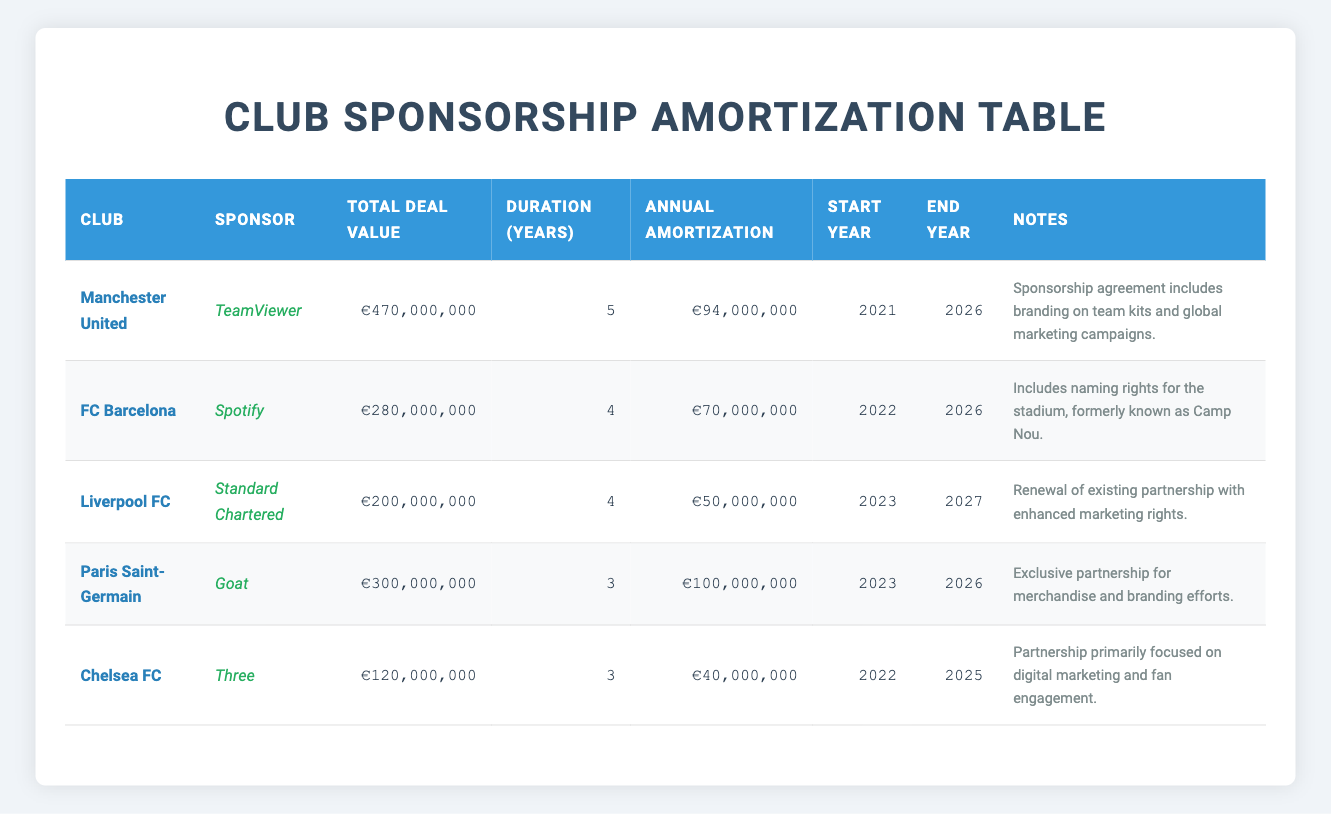What is the total deal value for FC Barcelona's sponsorship with Spotify? The total deal value for FC Barcelona's sponsorship with Spotify is listed in the table under the "Total Deal Value" column. It shows €280,000,000.
Answer: €280,000,000 Which club has the highest annual amortization and what is that amount? By examining the "Annual Amortization" column for each club, Paris Saint-Germain has the highest annual amortization of €100,000,000.
Answer: €100,000,000 Is the sponsorship deal with Three for Chelsea FC longer than 3 years? The table indicates that the deal duration for Chelsea FC's sponsorship with Three is 3 years. Therefore, it is not longer than 3 years.
Answer: No How much total value do Liverpool FC and Chelsea FC's sponsorship deals add together? To find the total value, we sum the total deal values of both clubs: Liverpool FC (€200,000,000) + Chelsea FC (€120,000,000) = €320,000,000.
Answer: €320,000,000 Does the sponsorship agreement for Manchester United include branding on team kits? The notes for Manchester United's sponsorship state that it includes branding on team kits and global marketing campaigns.
Answer: Yes What is the duration of the sponsorship deal between Paris Saint-Germain and Goat in years? The duration of the deal for Paris Saint-Germain with Goat is explicitly mentioned in the "Duration (Years)" column as 3 years.
Answer: 3 Which club's sponsorship deal ends first, and what is the ending year? By looking at the "End Year" column, Chelsea FC's sponsorship with Three ends in 2025, which is the earliest ending year among the listed deals.
Answer: 2025 What is the average annual amortization of all the clubs listed in the table? To find the average annual amortization, we first sum all the annual amortizations: €94,000,000 (Manchester United) + €70,000,000 (FC Barcelona) + €50,000,000 (Liverpool FC) + €100,000,000 (Paris Saint-Germain) + €40,000,000 (Chelsea FC) = €354,000,000. Then, we divide that by the number of clubs (5): €354,000,000 / 5 = €70,800,000.
Answer: €70,800,000 What are the total sponsorship deal values from clubs that have an annual amortization of €50,000,000 or more? We look for clubs with an annual amortization of €50,000,000 or more: Manchester United (€470,000,000), FC Barcelona (€280,000,000), Liverpool FC (€200,000,000), and Paris Saint-Germain (€300,000,000). Their total is €470,000,000 + €280,000,000 + €200,000,000 + €300,000,000 = €1,250,000,000.
Answer: €1,250,000,000 